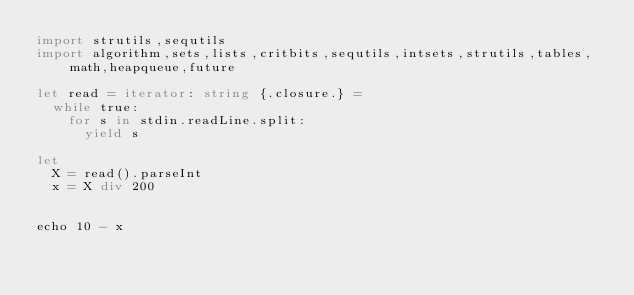<code> <loc_0><loc_0><loc_500><loc_500><_Nim_>import strutils,sequtils
import algorithm,sets,lists,critbits,sequtils,intsets,strutils,tables,math,heapqueue,future

let read = iterator: string {.closure.} =
  while true:
    for s in stdin.readLine.split:
      yield s

let
  X = read().parseInt
  x = X div 200


echo 10 - x
</code> 